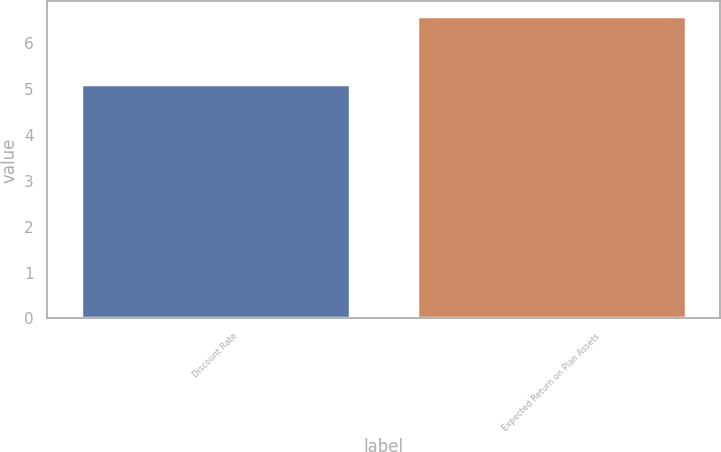Convert chart. <chart><loc_0><loc_0><loc_500><loc_500><bar_chart><fcel>Discount Rate<fcel>Expected Return on Plan Assets<nl><fcel>5.1<fcel>6.58<nl></chart> 